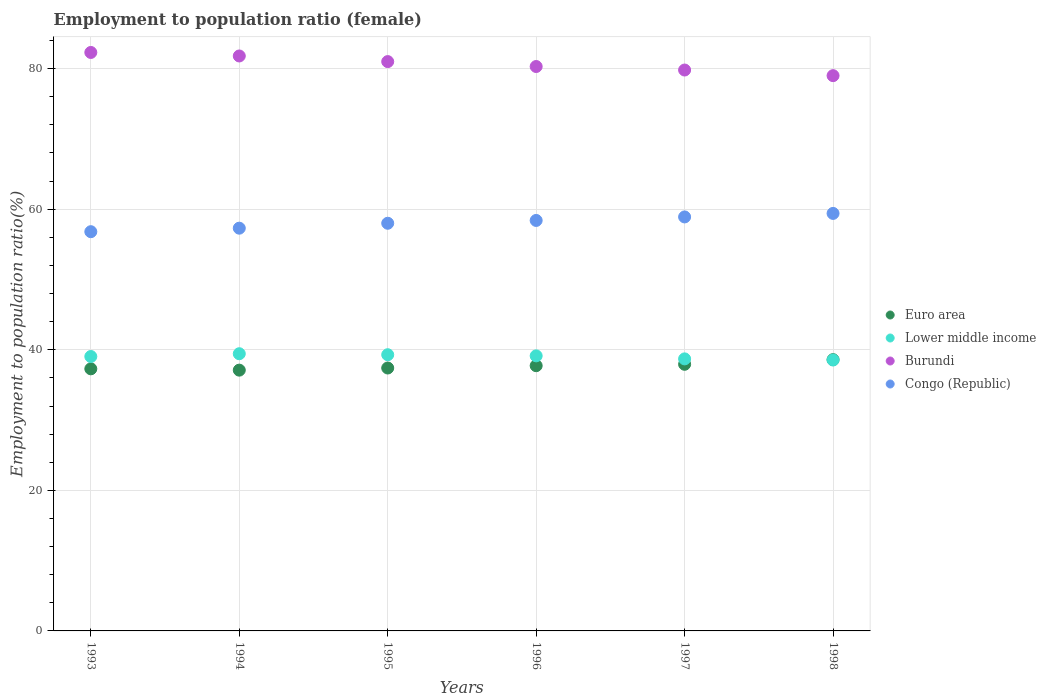How many different coloured dotlines are there?
Provide a short and direct response. 4. What is the employment to population ratio in Burundi in 1996?
Your answer should be compact. 80.3. Across all years, what is the maximum employment to population ratio in Lower middle income?
Your answer should be compact. 39.44. Across all years, what is the minimum employment to population ratio in Lower middle income?
Your response must be concise. 38.54. In which year was the employment to population ratio in Burundi maximum?
Your answer should be very brief. 1993. In which year was the employment to population ratio in Lower middle income minimum?
Give a very brief answer. 1998. What is the total employment to population ratio in Congo (Republic) in the graph?
Provide a short and direct response. 348.8. What is the difference between the employment to population ratio in Lower middle income in 1996 and that in 1997?
Ensure brevity in your answer.  0.43. What is the difference between the employment to population ratio in Lower middle income in 1998 and the employment to population ratio in Congo (Republic) in 1994?
Make the answer very short. -18.76. What is the average employment to population ratio in Burundi per year?
Your response must be concise. 80.7. In the year 1996, what is the difference between the employment to population ratio in Congo (Republic) and employment to population ratio in Lower middle income?
Ensure brevity in your answer.  19.27. What is the ratio of the employment to population ratio in Euro area in 1993 to that in 1996?
Provide a succinct answer. 0.99. Is the difference between the employment to population ratio in Congo (Republic) in 1996 and 1997 greater than the difference between the employment to population ratio in Lower middle income in 1996 and 1997?
Offer a terse response. No. What is the difference between the highest and the second highest employment to population ratio in Lower middle income?
Give a very brief answer. 0.14. What is the difference between the highest and the lowest employment to population ratio in Euro area?
Your response must be concise. 1.49. Is it the case that in every year, the sum of the employment to population ratio in Burundi and employment to population ratio in Lower middle income  is greater than the sum of employment to population ratio in Congo (Republic) and employment to population ratio in Euro area?
Ensure brevity in your answer.  Yes. Is it the case that in every year, the sum of the employment to population ratio in Lower middle income and employment to population ratio in Congo (Republic)  is greater than the employment to population ratio in Euro area?
Provide a succinct answer. Yes. Is the employment to population ratio in Congo (Republic) strictly greater than the employment to population ratio in Euro area over the years?
Make the answer very short. Yes. How many dotlines are there?
Provide a succinct answer. 4. Are the values on the major ticks of Y-axis written in scientific E-notation?
Provide a short and direct response. No. Does the graph contain any zero values?
Provide a short and direct response. No. Does the graph contain grids?
Offer a terse response. Yes. How are the legend labels stacked?
Offer a very short reply. Vertical. What is the title of the graph?
Offer a very short reply. Employment to population ratio (female). Does "South Sudan" appear as one of the legend labels in the graph?
Your answer should be compact. No. What is the label or title of the X-axis?
Your answer should be very brief. Years. What is the Employment to population ratio(%) of Euro area in 1993?
Keep it short and to the point. 37.29. What is the Employment to population ratio(%) in Lower middle income in 1993?
Keep it short and to the point. 39.04. What is the Employment to population ratio(%) of Burundi in 1993?
Make the answer very short. 82.3. What is the Employment to population ratio(%) of Congo (Republic) in 1993?
Give a very brief answer. 56.8. What is the Employment to population ratio(%) of Euro area in 1994?
Offer a very short reply. 37.1. What is the Employment to population ratio(%) in Lower middle income in 1994?
Offer a very short reply. 39.44. What is the Employment to population ratio(%) of Burundi in 1994?
Your answer should be compact. 81.8. What is the Employment to population ratio(%) of Congo (Republic) in 1994?
Make the answer very short. 57.3. What is the Employment to population ratio(%) in Euro area in 1995?
Provide a succinct answer. 37.41. What is the Employment to population ratio(%) of Lower middle income in 1995?
Provide a succinct answer. 39.3. What is the Employment to population ratio(%) of Burundi in 1995?
Provide a short and direct response. 81. What is the Employment to population ratio(%) of Congo (Republic) in 1995?
Your answer should be compact. 58. What is the Employment to population ratio(%) of Euro area in 1996?
Provide a succinct answer. 37.73. What is the Employment to population ratio(%) of Lower middle income in 1996?
Your answer should be compact. 39.13. What is the Employment to population ratio(%) of Burundi in 1996?
Make the answer very short. 80.3. What is the Employment to population ratio(%) in Congo (Republic) in 1996?
Offer a terse response. 58.4. What is the Employment to population ratio(%) of Euro area in 1997?
Make the answer very short. 37.94. What is the Employment to population ratio(%) in Lower middle income in 1997?
Make the answer very short. 38.7. What is the Employment to population ratio(%) of Burundi in 1997?
Provide a succinct answer. 79.8. What is the Employment to population ratio(%) of Congo (Republic) in 1997?
Your answer should be very brief. 58.9. What is the Employment to population ratio(%) in Euro area in 1998?
Ensure brevity in your answer.  38.59. What is the Employment to population ratio(%) of Lower middle income in 1998?
Provide a succinct answer. 38.54. What is the Employment to population ratio(%) of Burundi in 1998?
Offer a very short reply. 79. What is the Employment to population ratio(%) of Congo (Republic) in 1998?
Make the answer very short. 59.4. Across all years, what is the maximum Employment to population ratio(%) in Euro area?
Offer a very short reply. 38.59. Across all years, what is the maximum Employment to population ratio(%) of Lower middle income?
Your answer should be compact. 39.44. Across all years, what is the maximum Employment to population ratio(%) of Burundi?
Provide a succinct answer. 82.3. Across all years, what is the maximum Employment to population ratio(%) of Congo (Republic)?
Give a very brief answer. 59.4. Across all years, what is the minimum Employment to population ratio(%) of Euro area?
Offer a very short reply. 37.1. Across all years, what is the minimum Employment to population ratio(%) of Lower middle income?
Ensure brevity in your answer.  38.54. Across all years, what is the minimum Employment to population ratio(%) in Burundi?
Ensure brevity in your answer.  79. Across all years, what is the minimum Employment to population ratio(%) of Congo (Republic)?
Give a very brief answer. 56.8. What is the total Employment to population ratio(%) of Euro area in the graph?
Ensure brevity in your answer.  226.06. What is the total Employment to population ratio(%) in Lower middle income in the graph?
Keep it short and to the point. 234.16. What is the total Employment to population ratio(%) in Burundi in the graph?
Ensure brevity in your answer.  484.2. What is the total Employment to population ratio(%) of Congo (Republic) in the graph?
Provide a succinct answer. 348.8. What is the difference between the Employment to population ratio(%) in Euro area in 1993 and that in 1994?
Ensure brevity in your answer.  0.19. What is the difference between the Employment to population ratio(%) in Lower middle income in 1993 and that in 1994?
Provide a short and direct response. -0.4. What is the difference between the Employment to population ratio(%) in Burundi in 1993 and that in 1994?
Your answer should be compact. 0.5. What is the difference between the Employment to population ratio(%) of Euro area in 1993 and that in 1995?
Provide a short and direct response. -0.12. What is the difference between the Employment to population ratio(%) in Lower middle income in 1993 and that in 1995?
Your response must be concise. -0.25. What is the difference between the Employment to population ratio(%) of Burundi in 1993 and that in 1995?
Provide a short and direct response. 1.3. What is the difference between the Employment to population ratio(%) in Congo (Republic) in 1993 and that in 1995?
Your answer should be very brief. -1.2. What is the difference between the Employment to population ratio(%) in Euro area in 1993 and that in 1996?
Give a very brief answer. -0.45. What is the difference between the Employment to population ratio(%) in Lower middle income in 1993 and that in 1996?
Ensure brevity in your answer.  -0.09. What is the difference between the Employment to population ratio(%) in Congo (Republic) in 1993 and that in 1996?
Provide a short and direct response. -1.6. What is the difference between the Employment to population ratio(%) of Euro area in 1993 and that in 1997?
Provide a succinct answer. -0.65. What is the difference between the Employment to population ratio(%) in Lower middle income in 1993 and that in 1997?
Your answer should be very brief. 0.34. What is the difference between the Employment to population ratio(%) of Burundi in 1993 and that in 1997?
Your answer should be compact. 2.5. What is the difference between the Employment to population ratio(%) in Euro area in 1993 and that in 1998?
Your response must be concise. -1.31. What is the difference between the Employment to population ratio(%) in Lower middle income in 1993 and that in 1998?
Provide a succinct answer. 0.5. What is the difference between the Employment to population ratio(%) in Euro area in 1994 and that in 1995?
Ensure brevity in your answer.  -0.3. What is the difference between the Employment to population ratio(%) in Lower middle income in 1994 and that in 1995?
Offer a terse response. 0.14. What is the difference between the Employment to population ratio(%) in Congo (Republic) in 1994 and that in 1995?
Give a very brief answer. -0.7. What is the difference between the Employment to population ratio(%) in Euro area in 1994 and that in 1996?
Give a very brief answer. -0.63. What is the difference between the Employment to population ratio(%) of Lower middle income in 1994 and that in 1996?
Your answer should be compact. 0.3. What is the difference between the Employment to population ratio(%) of Burundi in 1994 and that in 1996?
Offer a terse response. 1.5. What is the difference between the Employment to population ratio(%) of Congo (Republic) in 1994 and that in 1996?
Offer a terse response. -1.1. What is the difference between the Employment to population ratio(%) of Euro area in 1994 and that in 1997?
Ensure brevity in your answer.  -0.83. What is the difference between the Employment to population ratio(%) in Lower middle income in 1994 and that in 1997?
Offer a very short reply. 0.73. What is the difference between the Employment to population ratio(%) of Euro area in 1994 and that in 1998?
Ensure brevity in your answer.  -1.49. What is the difference between the Employment to population ratio(%) in Lower middle income in 1994 and that in 1998?
Your answer should be compact. 0.89. What is the difference between the Employment to population ratio(%) of Burundi in 1994 and that in 1998?
Ensure brevity in your answer.  2.8. What is the difference between the Employment to population ratio(%) of Euro area in 1995 and that in 1996?
Keep it short and to the point. -0.33. What is the difference between the Employment to population ratio(%) in Lower middle income in 1995 and that in 1996?
Provide a short and direct response. 0.16. What is the difference between the Employment to population ratio(%) in Burundi in 1995 and that in 1996?
Give a very brief answer. 0.7. What is the difference between the Employment to population ratio(%) of Congo (Republic) in 1995 and that in 1996?
Your response must be concise. -0.4. What is the difference between the Employment to population ratio(%) in Euro area in 1995 and that in 1997?
Offer a terse response. -0.53. What is the difference between the Employment to population ratio(%) in Lower middle income in 1995 and that in 1997?
Ensure brevity in your answer.  0.59. What is the difference between the Employment to population ratio(%) of Burundi in 1995 and that in 1997?
Offer a very short reply. 1.2. What is the difference between the Employment to population ratio(%) in Congo (Republic) in 1995 and that in 1997?
Provide a succinct answer. -0.9. What is the difference between the Employment to population ratio(%) in Euro area in 1995 and that in 1998?
Ensure brevity in your answer.  -1.19. What is the difference between the Employment to population ratio(%) in Lower middle income in 1995 and that in 1998?
Your answer should be compact. 0.75. What is the difference between the Employment to population ratio(%) in Euro area in 1996 and that in 1997?
Your answer should be very brief. -0.2. What is the difference between the Employment to population ratio(%) of Lower middle income in 1996 and that in 1997?
Give a very brief answer. 0.43. What is the difference between the Employment to population ratio(%) in Euro area in 1996 and that in 1998?
Offer a terse response. -0.86. What is the difference between the Employment to population ratio(%) in Lower middle income in 1996 and that in 1998?
Keep it short and to the point. 0.59. What is the difference between the Employment to population ratio(%) in Burundi in 1996 and that in 1998?
Offer a very short reply. 1.3. What is the difference between the Employment to population ratio(%) in Congo (Republic) in 1996 and that in 1998?
Provide a short and direct response. -1. What is the difference between the Employment to population ratio(%) of Euro area in 1997 and that in 1998?
Your response must be concise. -0.66. What is the difference between the Employment to population ratio(%) in Lower middle income in 1997 and that in 1998?
Your response must be concise. 0.16. What is the difference between the Employment to population ratio(%) in Burundi in 1997 and that in 1998?
Your answer should be compact. 0.8. What is the difference between the Employment to population ratio(%) of Euro area in 1993 and the Employment to population ratio(%) of Lower middle income in 1994?
Give a very brief answer. -2.15. What is the difference between the Employment to population ratio(%) of Euro area in 1993 and the Employment to population ratio(%) of Burundi in 1994?
Keep it short and to the point. -44.51. What is the difference between the Employment to population ratio(%) of Euro area in 1993 and the Employment to population ratio(%) of Congo (Republic) in 1994?
Make the answer very short. -20.01. What is the difference between the Employment to population ratio(%) in Lower middle income in 1993 and the Employment to population ratio(%) in Burundi in 1994?
Give a very brief answer. -42.76. What is the difference between the Employment to population ratio(%) of Lower middle income in 1993 and the Employment to population ratio(%) of Congo (Republic) in 1994?
Provide a succinct answer. -18.26. What is the difference between the Employment to population ratio(%) of Euro area in 1993 and the Employment to population ratio(%) of Lower middle income in 1995?
Offer a terse response. -2.01. What is the difference between the Employment to population ratio(%) in Euro area in 1993 and the Employment to population ratio(%) in Burundi in 1995?
Give a very brief answer. -43.71. What is the difference between the Employment to population ratio(%) of Euro area in 1993 and the Employment to population ratio(%) of Congo (Republic) in 1995?
Ensure brevity in your answer.  -20.71. What is the difference between the Employment to population ratio(%) of Lower middle income in 1993 and the Employment to population ratio(%) of Burundi in 1995?
Keep it short and to the point. -41.96. What is the difference between the Employment to population ratio(%) of Lower middle income in 1993 and the Employment to population ratio(%) of Congo (Republic) in 1995?
Give a very brief answer. -18.96. What is the difference between the Employment to population ratio(%) in Burundi in 1993 and the Employment to population ratio(%) in Congo (Republic) in 1995?
Offer a very short reply. 24.3. What is the difference between the Employment to population ratio(%) in Euro area in 1993 and the Employment to population ratio(%) in Lower middle income in 1996?
Give a very brief answer. -1.84. What is the difference between the Employment to population ratio(%) of Euro area in 1993 and the Employment to population ratio(%) of Burundi in 1996?
Your response must be concise. -43.01. What is the difference between the Employment to population ratio(%) in Euro area in 1993 and the Employment to population ratio(%) in Congo (Republic) in 1996?
Offer a terse response. -21.11. What is the difference between the Employment to population ratio(%) of Lower middle income in 1993 and the Employment to population ratio(%) of Burundi in 1996?
Provide a succinct answer. -41.26. What is the difference between the Employment to population ratio(%) of Lower middle income in 1993 and the Employment to population ratio(%) of Congo (Republic) in 1996?
Your answer should be very brief. -19.36. What is the difference between the Employment to population ratio(%) of Burundi in 1993 and the Employment to population ratio(%) of Congo (Republic) in 1996?
Your answer should be very brief. 23.9. What is the difference between the Employment to population ratio(%) of Euro area in 1993 and the Employment to population ratio(%) of Lower middle income in 1997?
Offer a terse response. -1.42. What is the difference between the Employment to population ratio(%) in Euro area in 1993 and the Employment to population ratio(%) in Burundi in 1997?
Offer a terse response. -42.51. What is the difference between the Employment to population ratio(%) in Euro area in 1993 and the Employment to population ratio(%) in Congo (Republic) in 1997?
Offer a terse response. -21.61. What is the difference between the Employment to population ratio(%) in Lower middle income in 1993 and the Employment to population ratio(%) in Burundi in 1997?
Your answer should be compact. -40.76. What is the difference between the Employment to population ratio(%) of Lower middle income in 1993 and the Employment to population ratio(%) of Congo (Republic) in 1997?
Offer a terse response. -19.86. What is the difference between the Employment to population ratio(%) of Burundi in 1993 and the Employment to population ratio(%) of Congo (Republic) in 1997?
Your answer should be compact. 23.4. What is the difference between the Employment to population ratio(%) of Euro area in 1993 and the Employment to population ratio(%) of Lower middle income in 1998?
Provide a short and direct response. -1.25. What is the difference between the Employment to population ratio(%) in Euro area in 1993 and the Employment to population ratio(%) in Burundi in 1998?
Provide a short and direct response. -41.71. What is the difference between the Employment to population ratio(%) in Euro area in 1993 and the Employment to population ratio(%) in Congo (Republic) in 1998?
Offer a very short reply. -22.11. What is the difference between the Employment to population ratio(%) of Lower middle income in 1993 and the Employment to population ratio(%) of Burundi in 1998?
Your answer should be compact. -39.96. What is the difference between the Employment to population ratio(%) of Lower middle income in 1993 and the Employment to population ratio(%) of Congo (Republic) in 1998?
Your response must be concise. -20.36. What is the difference between the Employment to population ratio(%) in Burundi in 1993 and the Employment to population ratio(%) in Congo (Republic) in 1998?
Give a very brief answer. 22.9. What is the difference between the Employment to population ratio(%) in Euro area in 1994 and the Employment to population ratio(%) in Lower middle income in 1995?
Provide a short and direct response. -2.19. What is the difference between the Employment to population ratio(%) in Euro area in 1994 and the Employment to population ratio(%) in Burundi in 1995?
Offer a terse response. -43.9. What is the difference between the Employment to population ratio(%) in Euro area in 1994 and the Employment to population ratio(%) in Congo (Republic) in 1995?
Give a very brief answer. -20.9. What is the difference between the Employment to population ratio(%) of Lower middle income in 1994 and the Employment to population ratio(%) of Burundi in 1995?
Give a very brief answer. -41.56. What is the difference between the Employment to population ratio(%) in Lower middle income in 1994 and the Employment to population ratio(%) in Congo (Republic) in 1995?
Your response must be concise. -18.56. What is the difference between the Employment to population ratio(%) in Burundi in 1994 and the Employment to population ratio(%) in Congo (Republic) in 1995?
Your answer should be very brief. 23.8. What is the difference between the Employment to population ratio(%) of Euro area in 1994 and the Employment to population ratio(%) of Lower middle income in 1996?
Offer a terse response. -2.03. What is the difference between the Employment to population ratio(%) in Euro area in 1994 and the Employment to population ratio(%) in Burundi in 1996?
Your answer should be very brief. -43.2. What is the difference between the Employment to population ratio(%) of Euro area in 1994 and the Employment to population ratio(%) of Congo (Republic) in 1996?
Ensure brevity in your answer.  -21.3. What is the difference between the Employment to population ratio(%) in Lower middle income in 1994 and the Employment to population ratio(%) in Burundi in 1996?
Offer a terse response. -40.86. What is the difference between the Employment to population ratio(%) in Lower middle income in 1994 and the Employment to population ratio(%) in Congo (Republic) in 1996?
Provide a succinct answer. -18.96. What is the difference between the Employment to population ratio(%) in Burundi in 1994 and the Employment to population ratio(%) in Congo (Republic) in 1996?
Offer a very short reply. 23.4. What is the difference between the Employment to population ratio(%) in Euro area in 1994 and the Employment to population ratio(%) in Lower middle income in 1997?
Provide a short and direct response. -1.6. What is the difference between the Employment to population ratio(%) of Euro area in 1994 and the Employment to population ratio(%) of Burundi in 1997?
Offer a very short reply. -42.7. What is the difference between the Employment to population ratio(%) in Euro area in 1994 and the Employment to population ratio(%) in Congo (Republic) in 1997?
Your answer should be compact. -21.8. What is the difference between the Employment to population ratio(%) of Lower middle income in 1994 and the Employment to population ratio(%) of Burundi in 1997?
Provide a short and direct response. -40.36. What is the difference between the Employment to population ratio(%) in Lower middle income in 1994 and the Employment to population ratio(%) in Congo (Republic) in 1997?
Your answer should be very brief. -19.46. What is the difference between the Employment to population ratio(%) in Burundi in 1994 and the Employment to population ratio(%) in Congo (Republic) in 1997?
Make the answer very short. 22.9. What is the difference between the Employment to population ratio(%) in Euro area in 1994 and the Employment to population ratio(%) in Lower middle income in 1998?
Offer a very short reply. -1.44. What is the difference between the Employment to population ratio(%) in Euro area in 1994 and the Employment to population ratio(%) in Burundi in 1998?
Offer a terse response. -41.9. What is the difference between the Employment to population ratio(%) in Euro area in 1994 and the Employment to population ratio(%) in Congo (Republic) in 1998?
Make the answer very short. -22.3. What is the difference between the Employment to population ratio(%) of Lower middle income in 1994 and the Employment to population ratio(%) of Burundi in 1998?
Your answer should be compact. -39.56. What is the difference between the Employment to population ratio(%) of Lower middle income in 1994 and the Employment to population ratio(%) of Congo (Republic) in 1998?
Your response must be concise. -19.96. What is the difference between the Employment to population ratio(%) of Burundi in 1994 and the Employment to population ratio(%) of Congo (Republic) in 1998?
Offer a terse response. 22.4. What is the difference between the Employment to population ratio(%) of Euro area in 1995 and the Employment to population ratio(%) of Lower middle income in 1996?
Your answer should be very brief. -1.73. What is the difference between the Employment to population ratio(%) in Euro area in 1995 and the Employment to population ratio(%) in Burundi in 1996?
Offer a very short reply. -42.89. What is the difference between the Employment to population ratio(%) of Euro area in 1995 and the Employment to population ratio(%) of Congo (Republic) in 1996?
Keep it short and to the point. -20.99. What is the difference between the Employment to population ratio(%) in Lower middle income in 1995 and the Employment to population ratio(%) in Burundi in 1996?
Offer a very short reply. -41. What is the difference between the Employment to population ratio(%) of Lower middle income in 1995 and the Employment to population ratio(%) of Congo (Republic) in 1996?
Ensure brevity in your answer.  -19.1. What is the difference between the Employment to population ratio(%) in Burundi in 1995 and the Employment to population ratio(%) in Congo (Republic) in 1996?
Make the answer very short. 22.6. What is the difference between the Employment to population ratio(%) in Euro area in 1995 and the Employment to population ratio(%) in Lower middle income in 1997?
Your answer should be compact. -1.3. What is the difference between the Employment to population ratio(%) of Euro area in 1995 and the Employment to population ratio(%) of Burundi in 1997?
Provide a short and direct response. -42.39. What is the difference between the Employment to population ratio(%) of Euro area in 1995 and the Employment to population ratio(%) of Congo (Republic) in 1997?
Offer a terse response. -21.49. What is the difference between the Employment to population ratio(%) of Lower middle income in 1995 and the Employment to population ratio(%) of Burundi in 1997?
Give a very brief answer. -40.5. What is the difference between the Employment to population ratio(%) in Lower middle income in 1995 and the Employment to population ratio(%) in Congo (Republic) in 1997?
Offer a terse response. -19.6. What is the difference between the Employment to population ratio(%) of Burundi in 1995 and the Employment to population ratio(%) of Congo (Republic) in 1997?
Offer a terse response. 22.1. What is the difference between the Employment to population ratio(%) of Euro area in 1995 and the Employment to population ratio(%) of Lower middle income in 1998?
Make the answer very short. -1.14. What is the difference between the Employment to population ratio(%) in Euro area in 1995 and the Employment to population ratio(%) in Burundi in 1998?
Provide a short and direct response. -41.59. What is the difference between the Employment to population ratio(%) in Euro area in 1995 and the Employment to population ratio(%) in Congo (Republic) in 1998?
Provide a short and direct response. -21.99. What is the difference between the Employment to population ratio(%) in Lower middle income in 1995 and the Employment to population ratio(%) in Burundi in 1998?
Give a very brief answer. -39.7. What is the difference between the Employment to population ratio(%) of Lower middle income in 1995 and the Employment to population ratio(%) of Congo (Republic) in 1998?
Provide a short and direct response. -20.1. What is the difference between the Employment to population ratio(%) of Burundi in 1995 and the Employment to population ratio(%) of Congo (Republic) in 1998?
Your response must be concise. 21.6. What is the difference between the Employment to population ratio(%) of Euro area in 1996 and the Employment to population ratio(%) of Lower middle income in 1997?
Your answer should be compact. -0.97. What is the difference between the Employment to population ratio(%) in Euro area in 1996 and the Employment to population ratio(%) in Burundi in 1997?
Keep it short and to the point. -42.07. What is the difference between the Employment to population ratio(%) in Euro area in 1996 and the Employment to population ratio(%) in Congo (Republic) in 1997?
Provide a succinct answer. -21.17. What is the difference between the Employment to population ratio(%) in Lower middle income in 1996 and the Employment to population ratio(%) in Burundi in 1997?
Provide a short and direct response. -40.67. What is the difference between the Employment to population ratio(%) of Lower middle income in 1996 and the Employment to population ratio(%) of Congo (Republic) in 1997?
Offer a terse response. -19.77. What is the difference between the Employment to population ratio(%) in Burundi in 1996 and the Employment to population ratio(%) in Congo (Republic) in 1997?
Give a very brief answer. 21.4. What is the difference between the Employment to population ratio(%) of Euro area in 1996 and the Employment to population ratio(%) of Lower middle income in 1998?
Provide a succinct answer. -0.81. What is the difference between the Employment to population ratio(%) in Euro area in 1996 and the Employment to population ratio(%) in Burundi in 1998?
Your answer should be very brief. -41.27. What is the difference between the Employment to population ratio(%) in Euro area in 1996 and the Employment to population ratio(%) in Congo (Republic) in 1998?
Ensure brevity in your answer.  -21.67. What is the difference between the Employment to population ratio(%) in Lower middle income in 1996 and the Employment to population ratio(%) in Burundi in 1998?
Your response must be concise. -39.87. What is the difference between the Employment to population ratio(%) in Lower middle income in 1996 and the Employment to population ratio(%) in Congo (Republic) in 1998?
Ensure brevity in your answer.  -20.27. What is the difference between the Employment to population ratio(%) in Burundi in 1996 and the Employment to population ratio(%) in Congo (Republic) in 1998?
Make the answer very short. 20.9. What is the difference between the Employment to population ratio(%) of Euro area in 1997 and the Employment to population ratio(%) of Lower middle income in 1998?
Ensure brevity in your answer.  -0.61. What is the difference between the Employment to population ratio(%) in Euro area in 1997 and the Employment to population ratio(%) in Burundi in 1998?
Provide a succinct answer. -41.06. What is the difference between the Employment to population ratio(%) of Euro area in 1997 and the Employment to population ratio(%) of Congo (Republic) in 1998?
Make the answer very short. -21.46. What is the difference between the Employment to population ratio(%) of Lower middle income in 1997 and the Employment to population ratio(%) of Burundi in 1998?
Your response must be concise. -40.3. What is the difference between the Employment to population ratio(%) of Lower middle income in 1997 and the Employment to population ratio(%) of Congo (Republic) in 1998?
Your answer should be compact. -20.7. What is the difference between the Employment to population ratio(%) in Burundi in 1997 and the Employment to population ratio(%) in Congo (Republic) in 1998?
Offer a terse response. 20.4. What is the average Employment to population ratio(%) of Euro area per year?
Give a very brief answer. 37.68. What is the average Employment to population ratio(%) of Lower middle income per year?
Offer a very short reply. 39.03. What is the average Employment to population ratio(%) in Burundi per year?
Make the answer very short. 80.7. What is the average Employment to population ratio(%) of Congo (Republic) per year?
Give a very brief answer. 58.13. In the year 1993, what is the difference between the Employment to population ratio(%) in Euro area and Employment to population ratio(%) in Lower middle income?
Your response must be concise. -1.75. In the year 1993, what is the difference between the Employment to population ratio(%) of Euro area and Employment to population ratio(%) of Burundi?
Your answer should be very brief. -45.01. In the year 1993, what is the difference between the Employment to population ratio(%) of Euro area and Employment to population ratio(%) of Congo (Republic)?
Your answer should be very brief. -19.51. In the year 1993, what is the difference between the Employment to population ratio(%) of Lower middle income and Employment to population ratio(%) of Burundi?
Provide a short and direct response. -43.26. In the year 1993, what is the difference between the Employment to population ratio(%) of Lower middle income and Employment to population ratio(%) of Congo (Republic)?
Offer a terse response. -17.76. In the year 1993, what is the difference between the Employment to population ratio(%) in Burundi and Employment to population ratio(%) in Congo (Republic)?
Offer a very short reply. 25.5. In the year 1994, what is the difference between the Employment to population ratio(%) of Euro area and Employment to population ratio(%) of Lower middle income?
Make the answer very short. -2.34. In the year 1994, what is the difference between the Employment to population ratio(%) in Euro area and Employment to population ratio(%) in Burundi?
Keep it short and to the point. -44.7. In the year 1994, what is the difference between the Employment to population ratio(%) in Euro area and Employment to population ratio(%) in Congo (Republic)?
Offer a terse response. -20.2. In the year 1994, what is the difference between the Employment to population ratio(%) in Lower middle income and Employment to population ratio(%) in Burundi?
Your answer should be compact. -42.36. In the year 1994, what is the difference between the Employment to population ratio(%) in Lower middle income and Employment to population ratio(%) in Congo (Republic)?
Give a very brief answer. -17.86. In the year 1995, what is the difference between the Employment to population ratio(%) of Euro area and Employment to population ratio(%) of Lower middle income?
Offer a very short reply. -1.89. In the year 1995, what is the difference between the Employment to population ratio(%) of Euro area and Employment to population ratio(%) of Burundi?
Your answer should be very brief. -43.59. In the year 1995, what is the difference between the Employment to population ratio(%) in Euro area and Employment to population ratio(%) in Congo (Republic)?
Your answer should be compact. -20.59. In the year 1995, what is the difference between the Employment to population ratio(%) of Lower middle income and Employment to population ratio(%) of Burundi?
Your response must be concise. -41.7. In the year 1995, what is the difference between the Employment to population ratio(%) in Lower middle income and Employment to population ratio(%) in Congo (Republic)?
Make the answer very short. -18.7. In the year 1996, what is the difference between the Employment to population ratio(%) of Euro area and Employment to population ratio(%) of Lower middle income?
Your answer should be compact. -1.4. In the year 1996, what is the difference between the Employment to population ratio(%) of Euro area and Employment to population ratio(%) of Burundi?
Make the answer very short. -42.57. In the year 1996, what is the difference between the Employment to population ratio(%) of Euro area and Employment to population ratio(%) of Congo (Republic)?
Make the answer very short. -20.67. In the year 1996, what is the difference between the Employment to population ratio(%) in Lower middle income and Employment to population ratio(%) in Burundi?
Your answer should be compact. -41.17. In the year 1996, what is the difference between the Employment to population ratio(%) of Lower middle income and Employment to population ratio(%) of Congo (Republic)?
Your response must be concise. -19.27. In the year 1996, what is the difference between the Employment to population ratio(%) of Burundi and Employment to population ratio(%) of Congo (Republic)?
Offer a terse response. 21.9. In the year 1997, what is the difference between the Employment to population ratio(%) in Euro area and Employment to population ratio(%) in Lower middle income?
Give a very brief answer. -0.77. In the year 1997, what is the difference between the Employment to population ratio(%) of Euro area and Employment to population ratio(%) of Burundi?
Offer a terse response. -41.86. In the year 1997, what is the difference between the Employment to population ratio(%) of Euro area and Employment to population ratio(%) of Congo (Republic)?
Offer a terse response. -20.96. In the year 1997, what is the difference between the Employment to population ratio(%) of Lower middle income and Employment to population ratio(%) of Burundi?
Keep it short and to the point. -41.1. In the year 1997, what is the difference between the Employment to population ratio(%) in Lower middle income and Employment to population ratio(%) in Congo (Republic)?
Provide a succinct answer. -20.2. In the year 1997, what is the difference between the Employment to population ratio(%) of Burundi and Employment to population ratio(%) of Congo (Republic)?
Offer a terse response. 20.9. In the year 1998, what is the difference between the Employment to population ratio(%) of Euro area and Employment to population ratio(%) of Lower middle income?
Keep it short and to the point. 0.05. In the year 1998, what is the difference between the Employment to population ratio(%) in Euro area and Employment to population ratio(%) in Burundi?
Offer a terse response. -40.41. In the year 1998, what is the difference between the Employment to population ratio(%) of Euro area and Employment to population ratio(%) of Congo (Republic)?
Make the answer very short. -20.81. In the year 1998, what is the difference between the Employment to population ratio(%) in Lower middle income and Employment to population ratio(%) in Burundi?
Provide a succinct answer. -40.46. In the year 1998, what is the difference between the Employment to population ratio(%) in Lower middle income and Employment to population ratio(%) in Congo (Republic)?
Provide a succinct answer. -20.86. In the year 1998, what is the difference between the Employment to population ratio(%) in Burundi and Employment to population ratio(%) in Congo (Republic)?
Provide a short and direct response. 19.6. What is the ratio of the Employment to population ratio(%) of Lower middle income in 1993 to that in 1994?
Make the answer very short. 0.99. What is the ratio of the Employment to population ratio(%) of Congo (Republic) in 1993 to that in 1994?
Your answer should be very brief. 0.99. What is the ratio of the Employment to population ratio(%) in Euro area in 1993 to that in 1995?
Your answer should be compact. 1. What is the ratio of the Employment to population ratio(%) in Burundi in 1993 to that in 1995?
Offer a terse response. 1.02. What is the ratio of the Employment to population ratio(%) in Congo (Republic) in 1993 to that in 1995?
Offer a very short reply. 0.98. What is the ratio of the Employment to population ratio(%) of Burundi in 1993 to that in 1996?
Give a very brief answer. 1.02. What is the ratio of the Employment to population ratio(%) in Congo (Republic) in 1993 to that in 1996?
Provide a succinct answer. 0.97. What is the ratio of the Employment to population ratio(%) in Lower middle income in 1993 to that in 1997?
Offer a very short reply. 1.01. What is the ratio of the Employment to population ratio(%) in Burundi in 1993 to that in 1997?
Provide a succinct answer. 1.03. What is the ratio of the Employment to population ratio(%) in Euro area in 1993 to that in 1998?
Provide a short and direct response. 0.97. What is the ratio of the Employment to population ratio(%) in Lower middle income in 1993 to that in 1998?
Ensure brevity in your answer.  1.01. What is the ratio of the Employment to population ratio(%) in Burundi in 1993 to that in 1998?
Your answer should be very brief. 1.04. What is the ratio of the Employment to population ratio(%) of Congo (Republic) in 1993 to that in 1998?
Give a very brief answer. 0.96. What is the ratio of the Employment to population ratio(%) in Euro area in 1994 to that in 1995?
Provide a short and direct response. 0.99. What is the ratio of the Employment to population ratio(%) in Lower middle income in 1994 to that in 1995?
Your answer should be very brief. 1. What is the ratio of the Employment to population ratio(%) of Burundi in 1994 to that in 1995?
Ensure brevity in your answer.  1.01. What is the ratio of the Employment to population ratio(%) in Congo (Republic) in 1994 to that in 1995?
Make the answer very short. 0.99. What is the ratio of the Employment to population ratio(%) in Euro area in 1994 to that in 1996?
Offer a terse response. 0.98. What is the ratio of the Employment to population ratio(%) of Lower middle income in 1994 to that in 1996?
Offer a very short reply. 1.01. What is the ratio of the Employment to population ratio(%) of Burundi in 1994 to that in 1996?
Give a very brief answer. 1.02. What is the ratio of the Employment to population ratio(%) in Congo (Republic) in 1994 to that in 1996?
Provide a succinct answer. 0.98. What is the ratio of the Employment to population ratio(%) of Lower middle income in 1994 to that in 1997?
Your response must be concise. 1.02. What is the ratio of the Employment to population ratio(%) in Burundi in 1994 to that in 1997?
Provide a short and direct response. 1.03. What is the ratio of the Employment to population ratio(%) in Congo (Republic) in 1994 to that in 1997?
Offer a terse response. 0.97. What is the ratio of the Employment to population ratio(%) in Euro area in 1994 to that in 1998?
Provide a short and direct response. 0.96. What is the ratio of the Employment to population ratio(%) in Lower middle income in 1994 to that in 1998?
Your answer should be compact. 1.02. What is the ratio of the Employment to population ratio(%) of Burundi in 1994 to that in 1998?
Give a very brief answer. 1.04. What is the ratio of the Employment to population ratio(%) of Congo (Republic) in 1994 to that in 1998?
Keep it short and to the point. 0.96. What is the ratio of the Employment to population ratio(%) in Euro area in 1995 to that in 1996?
Your response must be concise. 0.99. What is the ratio of the Employment to population ratio(%) of Lower middle income in 1995 to that in 1996?
Your response must be concise. 1. What is the ratio of the Employment to population ratio(%) of Burundi in 1995 to that in 1996?
Ensure brevity in your answer.  1.01. What is the ratio of the Employment to population ratio(%) of Euro area in 1995 to that in 1997?
Offer a very short reply. 0.99. What is the ratio of the Employment to population ratio(%) in Lower middle income in 1995 to that in 1997?
Ensure brevity in your answer.  1.02. What is the ratio of the Employment to population ratio(%) of Congo (Republic) in 1995 to that in 1997?
Make the answer very short. 0.98. What is the ratio of the Employment to population ratio(%) in Euro area in 1995 to that in 1998?
Your answer should be very brief. 0.97. What is the ratio of the Employment to population ratio(%) of Lower middle income in 1995 to that in 1998?
Give a very brief answer. 1.02. What is the ratio of the Employment to population ratio(%) of Burundi in 1995 to that in 1998?
Provide a succinct answer. 1.03. What is the ratio of the Employment to population ratio(%) of Congo (Republic) in 1995 to that in 1998?
Your response must be concise. 0.98. What is the ratio of the Employment to population ratio(%) in Euro area in 1996 to that in 1997?
Give a very brief answer. 0.99. What is the ratio of the Employment to population ratio(%) in Lower middle income in 1996 to that in 1997?
Keep it short and to the point. 1.01. What is the ratio of the Employment to population ratio(%) of Burundi in 1996 to that in 1997?
Your answer should be compact. 1.01. What is the ratio of the Employment to population ratio(%) of Euro area in 1996 to that in 1998?
Your answer should be very brief. 0.98. What is the ratio of the Employment to population ratio(%) of Lower middle income in 1996 to that in 1998?
Your answer should be very brief. 1.02. What is the ratio of the Employment to population ratio(%) in Burundi in 1996 to that in 1998?
Keep it short and to the point. 1.02. What is the ratio of the Employment to population ratio(%) in Congo (Republic) in 1996 to that in 1998?
Give a very brief answer. 0.98. What is the ratio of the Employment to population ratio(%) of Euro area in 1997 to that in 1998?
Keep it short and to the point. 0.98. What is the ratio of the Employment to population ratio(%) of Burundi in 1997 to that in 1998?
Offer a very short reply. 1.01. What is the difference between the highest and the second highest Employment to population ratio(%) of Euro area?
Make the answer very short. 0.66. What is the difference between the highest and the second highest Employment to population ratio(%) in Lower middle income?
Ensure brevity in your answer.  0.14. What is the difference between the highest and the second highest Employment to population ratio(%) of Burundi?
Keep it short and to the point. 0.5. What is the difference between the highest and the second highest Employment to population ratio(%) in Congo (Republic)?
Provide a succinct answer. 0.5. What is the difference between the highest and the lowest Employment to population ratio(%) in Euro area?
Ensure brevity in your answer.  1.49. What is the difference between the highest and the lowest Employment to population ratio(%) in Lower middle income?
Keep it short and to the point. 0.89. 